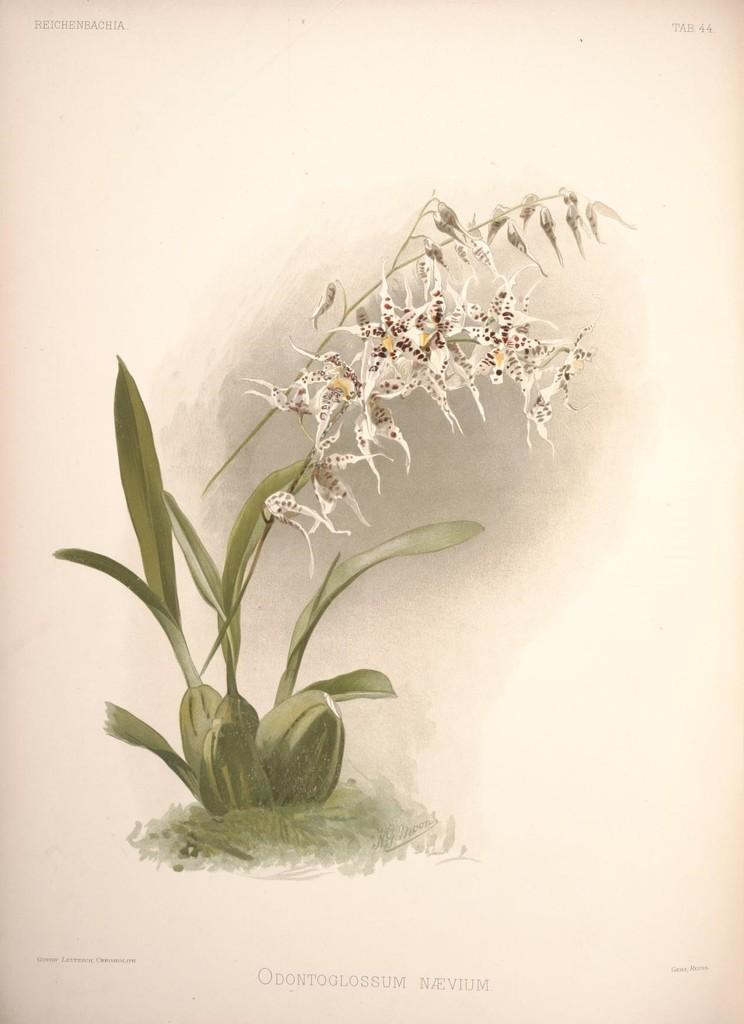What is depicted in the painting in the image? There is a painting of a plant and flowers in the image. What else can be seen in the image besides the painting? There is text in the image. What type of pancake is being served in the image? There is no pancake present in the image; it features a painting of a plant and flowers with text. What scent can be detected from the flowers in the image? The image is not a photograph, but a painting, and therefore, no scent can be detected from the flowers. 